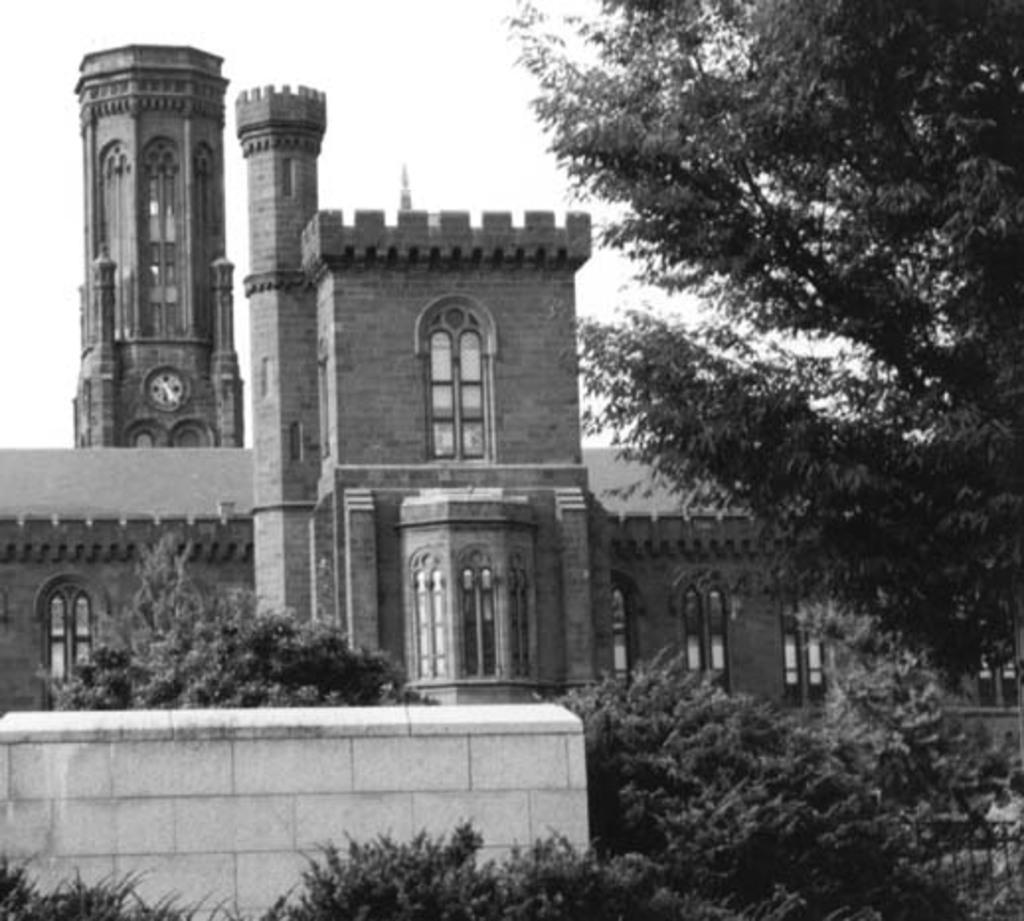What is the color scheme of the image? The image is black and white. What structure can be seen in the image? There is a building in the image. What type of vegetation is present in front of the building? There are trees in front of the building. What is visible behind the building? The sky is visible behind the building. What type of pipe is visible in the image? There is no pipe present in the image. What appliance can be seen on the building in the image? There is no appliance visible on the building in the image. 